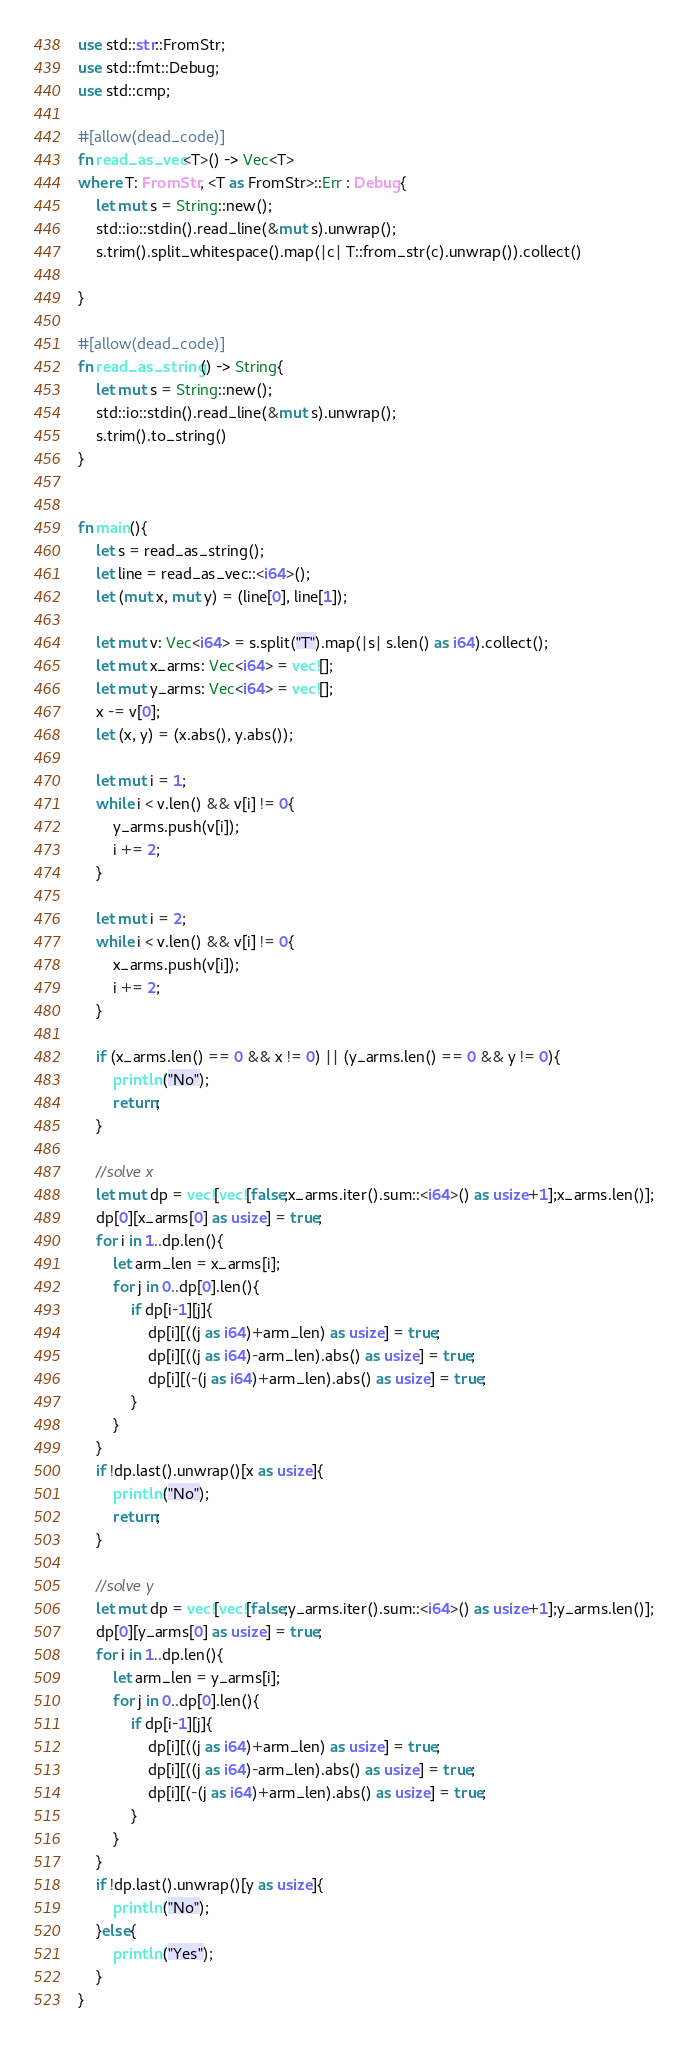Convert code to text. <code><loc_0><loc_0><loc_500><loc_500><_Rust_>use std::str::FromStr;
use std::fmt::Debug;
use std::cmp;

#[allow(dead_code)]
fn read_as_vec<T>() -> Vec<T>
where T: FromStr, <T as FromStr>::Err : Debug{
    let mut s = String::new();
    std::io::stdin().read_line(&mut s).unwrap();
    s.trim().split_whitespace().map(|c| T::from_str(c).unwrap()).collect()

}

#[allow(dead_code)]
fn read_as_string() -> String{
    let mut s = String::new();
    std::io::stdin().read_line(&mut s).unwrap();
    s.trim().to_string()
}


fn main(){
    let s = read_as_string();
    let line = read_as_vec::<i64>();
    let (mut x, mut y) = (line[0], line[1]);

    let mut v: Vec<i64> = s.split("T").map(|s| s.len() as i64).collect();
    let mut x_arms: Vec<i64> = vec![];
    let mut y_arms: Vec<i64> = vec![];
    x -= v[0];
    let (x, y) = (x.abs(), y.abs());

    let mut i = 1;
    while i < v.len() && v[i] != 0{
        y_arms.push(v[i]);
        i += 2;
    }

    let mut i = 2;
    while i < v.len() && v[i] != 0{
        x_arms.push(v[i]);
        i += 2;
    }

    if (x_arms.len() == 0 && x != 0) || (y_arms.len() == 0 && y != 0){
        println!("No");
        return;
    }

    //solve x
    let mut dp = vec![vec![false;x_arms.iter().sum::<i64>() as usize+1];x_arms.len()];
    dp[0][x_arms[0] as usize] = true;
    for i in 1..dp.len(){
        let arm_len = x_arms[i];
        for j in 0..dp[0].len(){
            if dp[i-1][j]{
                dp[i][((j as i64)+arm_len) as usize] = true;
                dp[i][((j as i64)-arm_len).abs() as usize] = true;
                dp[i][(-(j as i64)+arm_len).abs() as usize] = true;
            }
        }
    }
    if !dp.last().unwrap()[x as usize]{
        println!("No");
        return;
    }

    //solve y
    let mut dp = vec![vec![false;y_arms.iter().sum::<i64>() as usize+1];y_arms.len()];
    dp[0][y_arms[0] as usize] = true;
    for i in 1..dp.len(){
        let arm_len = y_arms[i];
        for j in 0..dp[0].len(){
            if dp[i-1][j]{
                dp[i][((j as i64)+arm_len) as usize] = true;
                dp[i][((j as i64)-arm_len).abs() as usize] = true;
                dp[i][(-(j as i64)+arm_len).abs() as usize] = true;
            }
        }
    }
    if !dp.last().unwrap()[y as usize]{
        println!("No");
    }else{
        println!("Yes");
    }
}
</code> 